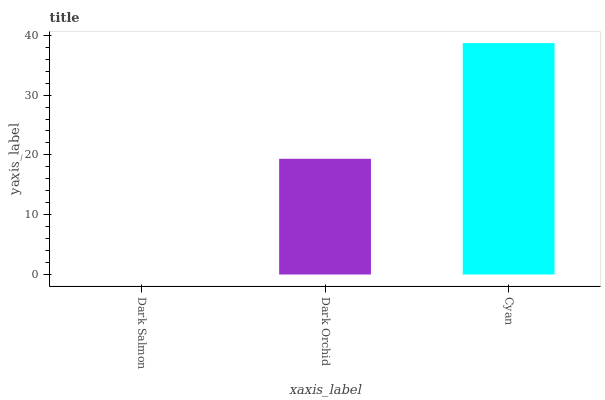Is Dark Salmon the minimum?
Answer yes or no. Yes. Is Cyan the maximum?
Answer yes or no. Yes. Is Dark Orchid the minimum?
Answer yes or no. No. Is Dark Orchid the maximum?
Answer yes or no. No. Is Dark Orchid greater than Dark Salmon?
Answer yes or no. Yes. Is Dark Salmon less than Dark Orchid?
Answer yes or no. Yes. Is Dark Salmon greater than Dark Orchid?
Answer yes or no. No. Is Dark Orchid less than Dark Salmon?
Answer yes or no. No. Is Dark Orchid the high median?
Answer yes or no. Yes. Is Dark Orchid the low median?
Answer yes or no. Yes. Is Dark Salmon the high median?
Answer yes or no. No. Is Dark Salmon the low median?
Answer yes or no. No. 